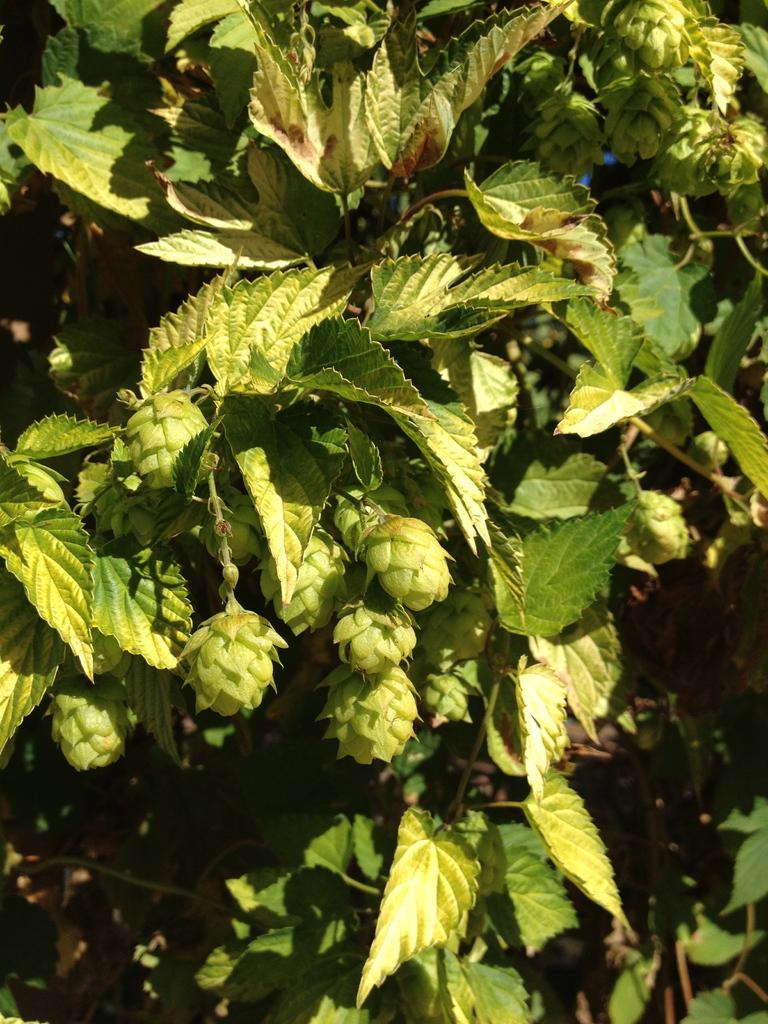What type of fruits can be seen on the tree in the image? There are green fruits on the tree in the image. What else can be seen in the front side of the image besides the tree? There are leaves in the front side of the image. Where is the throne located in the image? There is no throne present in the image. Can you describe the army formation in the image? There is no army or formation present in the image; it features a tree with green fruits and leaves. 